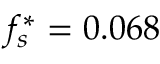<formula> <loc_0><loc_0><loc_500><loc_500>f _ { s } ^ { * } = 0 . 0 6 8</formula> 